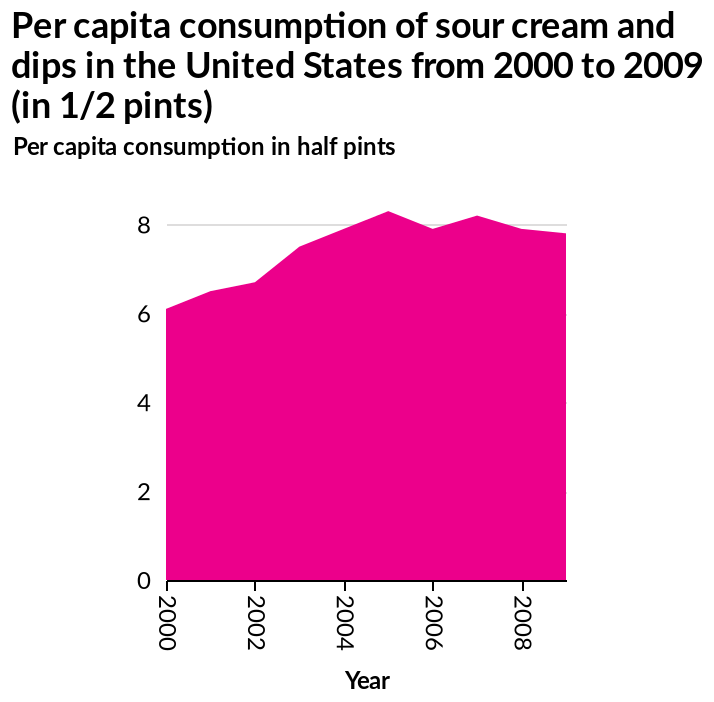<image>
What was the trend in sour cream and dips consumption in the United States from 2000-2009?  The trend in sour cream and dips consumption in the United States from 2000-2009 was an increase. What is the unit used to measure the per capita consumption of sour cream and dips in the United States?  The unit used to measure the per capita consumption of sour cream and dips in the United States is 1/2 pints. 